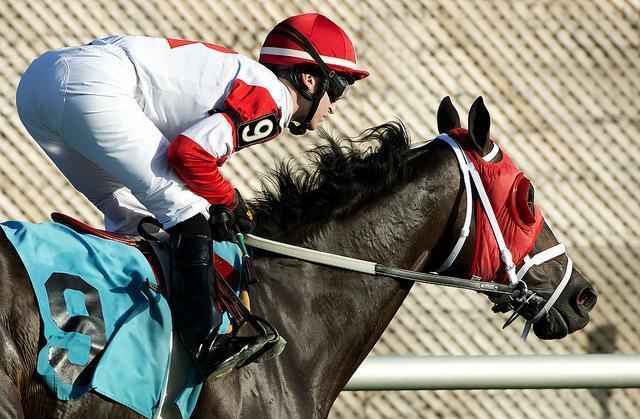How many pieces of cheese pizza are there?
Give a very brief answer. 0. 